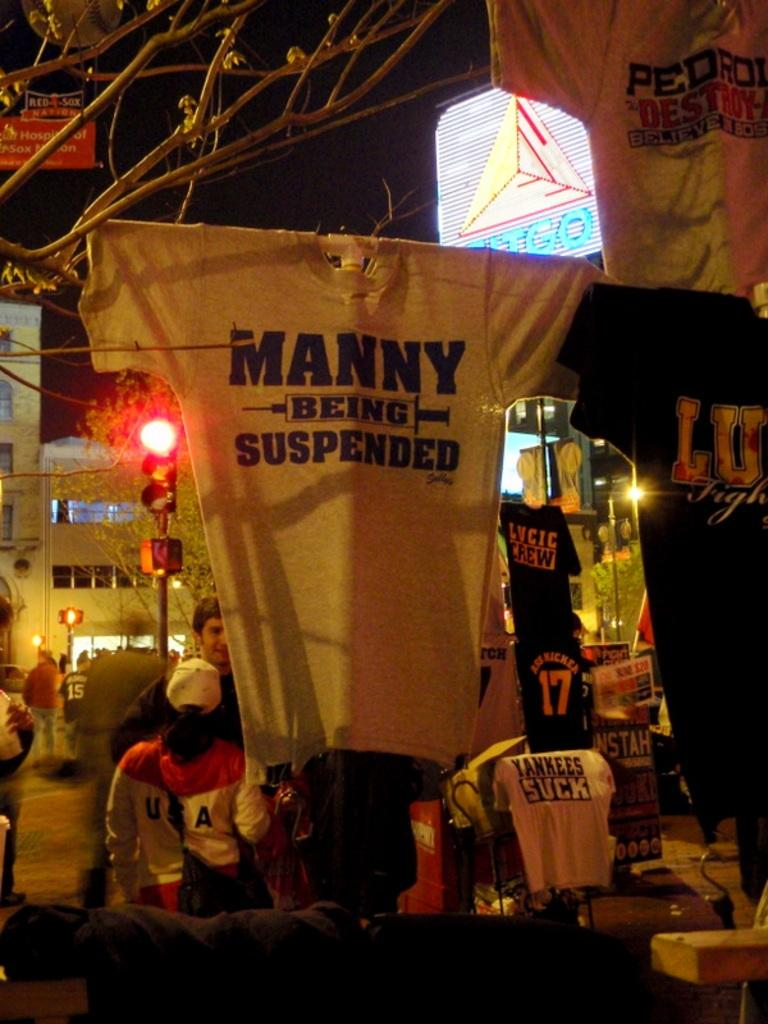How many people are in the image? There is a group of people in the image, but the exact number is not specified. What are the people wearing in the image? T-shirts are visible in the image. What can be seen in the background of the image? There are traffic lights, trees, poles, and buildings in the background of the image. What type of tail can be seen on the people in the image? There are no tails visible on the people in the image. What unit of measurement is used to determine the height of the buildings in the image? The provided facts do not specify a unit of measurement for the buildings in the image. 